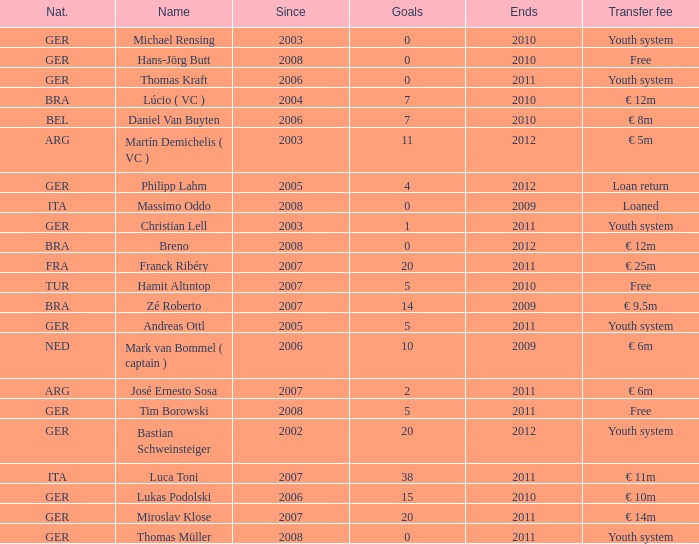In which year, after 2011, did the first transfer fee of €14m take place? None. 